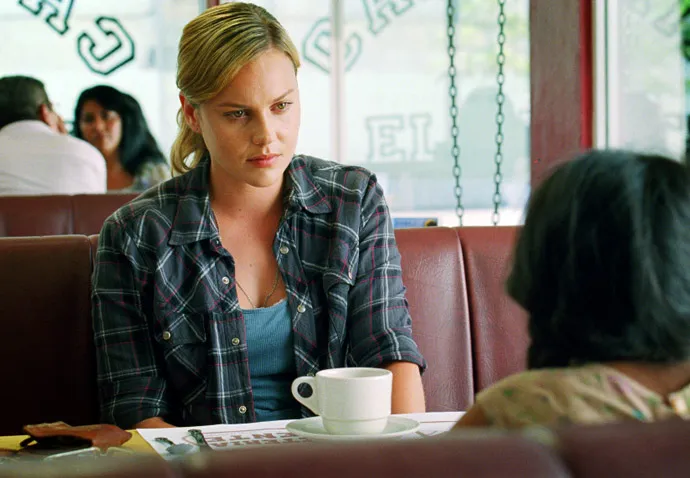Explain the visual content of the image in great detail. In this image, the focus is on a woman sitting in a diner booth. She is dressed in a blue and red plaid shirt over a gray tank top, and her blonde hair is pulled back in a low ponytail. On the table in front of her is a white coffee cup on a saucer, alongside some papers. Her expression is serious, and she seems to be deeply engaged in a conversation with someone seated across from her, although the other person's face is not visible. The background is slightly blurred but suggests a typical diner setting with other patrons sitting at booths and neon signs visible through the large windows, bringing a nostalgic, relaxed atmosphere to the scene. 